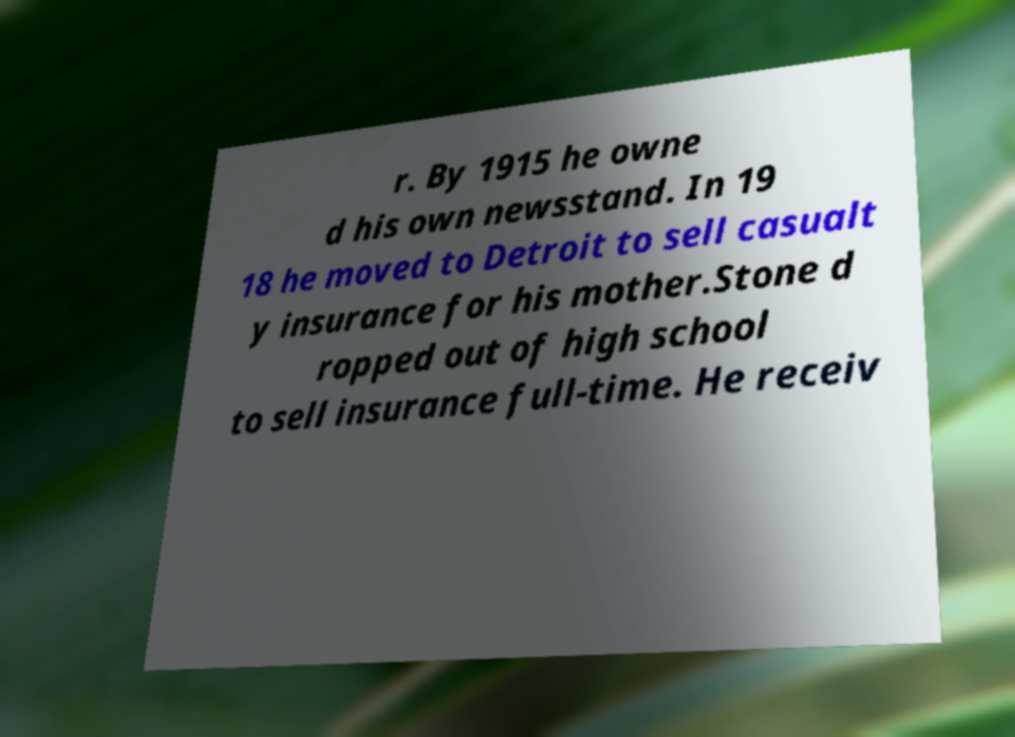For documentation purposes, I need the text within this image transcribed. Could you provide that? r. By 1915 he owne d his own newsstand. In 19 18 he moved to Detroit to sell casualt y insurance for his mother.Stone d ropped out of high school to sell insurance full-time. He receiv 